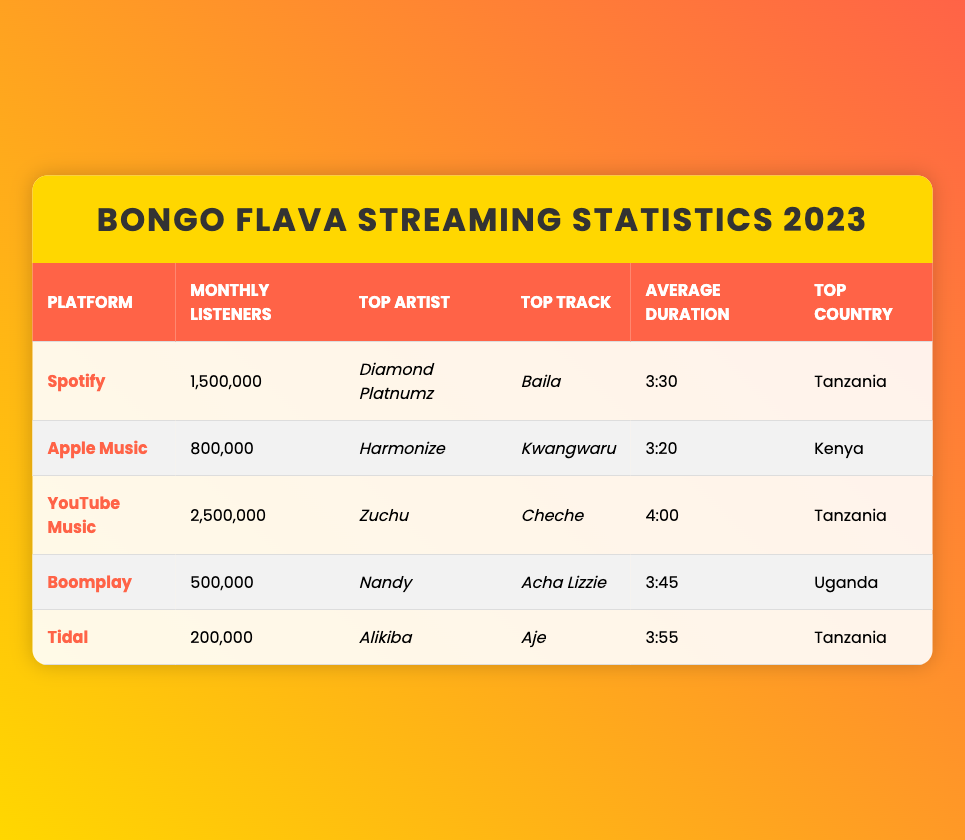What is the top artist on YouTube Music? The table lists YouTube Music under the platform column, and the corresponding top artist listed there is Zuchu.
Answer: Zuchu Which platform has the highest monthly listeners? By comparing the monthly listeners across all platforms, YouTube Music has the highest count at 2,500,000.
Answer: YouTube Music What is the average duration of the top track on Apple Music? Checking the Apple Music entry in the table shows that the average duration of the top track "Kwangwaru" is 3:20.
Answer: 3:20 Is Nandy the top artist on any streaming platform? The table shows Nandy as the top artist on Boomplay, confirming she is indeed a top artist on that platform.
Answer: Yes What is the total number of monthly listeners for Spotify and Tidal combined? The monthly listeners for Spotify is 1,500,000 and for Tidal is 200,000. Adding these two values gives a total of 1,700,000.
Answer: 1,700,000 Which country has the highest representation of top artists in the table? By looking at the top artists and their respective countries, Tanzania is represented by Diamond Platnumz, Zuchu, and Alikiba, so it has the highest representation.
Answer: Tanzania Is the top track on Boomplay longer than the top track on Spotify? The top track on Boomplay ("Acha Lizzie") has an average duration of 3:45 while Spotify's top track ("Baila") is 3:30. Since 3:45 is longer than 3:30, the answer is yes.
Answer: Yes Who has the most monthly listeners, Zuchu or Diamond Platnumz? Zuchu, who is the top artist on YouTube Music, has 2,500,000 monthly listeners, while Diamond Platnumz, the top artist on Spotify, has 1,500,000. Comparing these values shows Zuchu has more.
Answer: Zuchu Which platform has the lowest monthly listeners, and how many are there? The platform with the lowest monthly listeners is Tidal, which has 200,000 monthly listeners as stated in the table.
Answer: Tidal, 200,000 